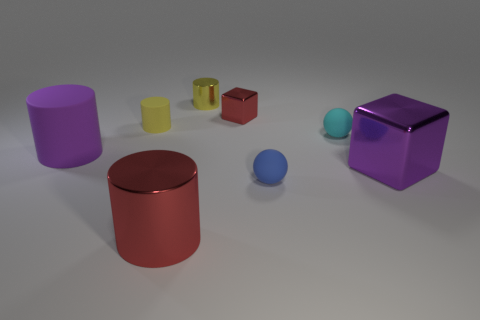What number of shiny things are there?
Make the answer very short. 4. Is there a cyan matte thing that has the same size as the purple metal object?
Keep it short and to the point. No. Is the material of the small blue ball the same as the tiny yellow thing that is left of the tiny yellow metallic cylinder?
Provide a short and direct response. Yes. There is a purple thing that is behind the big purple shiny cube; what material is it?
Ensure brevity in your answer.  Rubber. What size is the purple shiny object?
Your answer should be very brief. Large. Does the red thing that is on the right side of the tiny yellow metallic thing have the same size as the metal cube to the right of the blue ball?
Provide a succinct answer. No. There is a red shiny object that is the same shape as the yellow metallic object; what size is it?
Your answer should be very brief. Large. Is the size of the yellow rubber object the same as the shiny block in front of the cyan object?
Give a very brief answer. No. Is there a yellow cylinder behind the large object that is behind the purple cube?
Offer a very short reply. Yes. The matte object that is in front of the big purple block has what shape?
Your response must be concise. Sphere. 